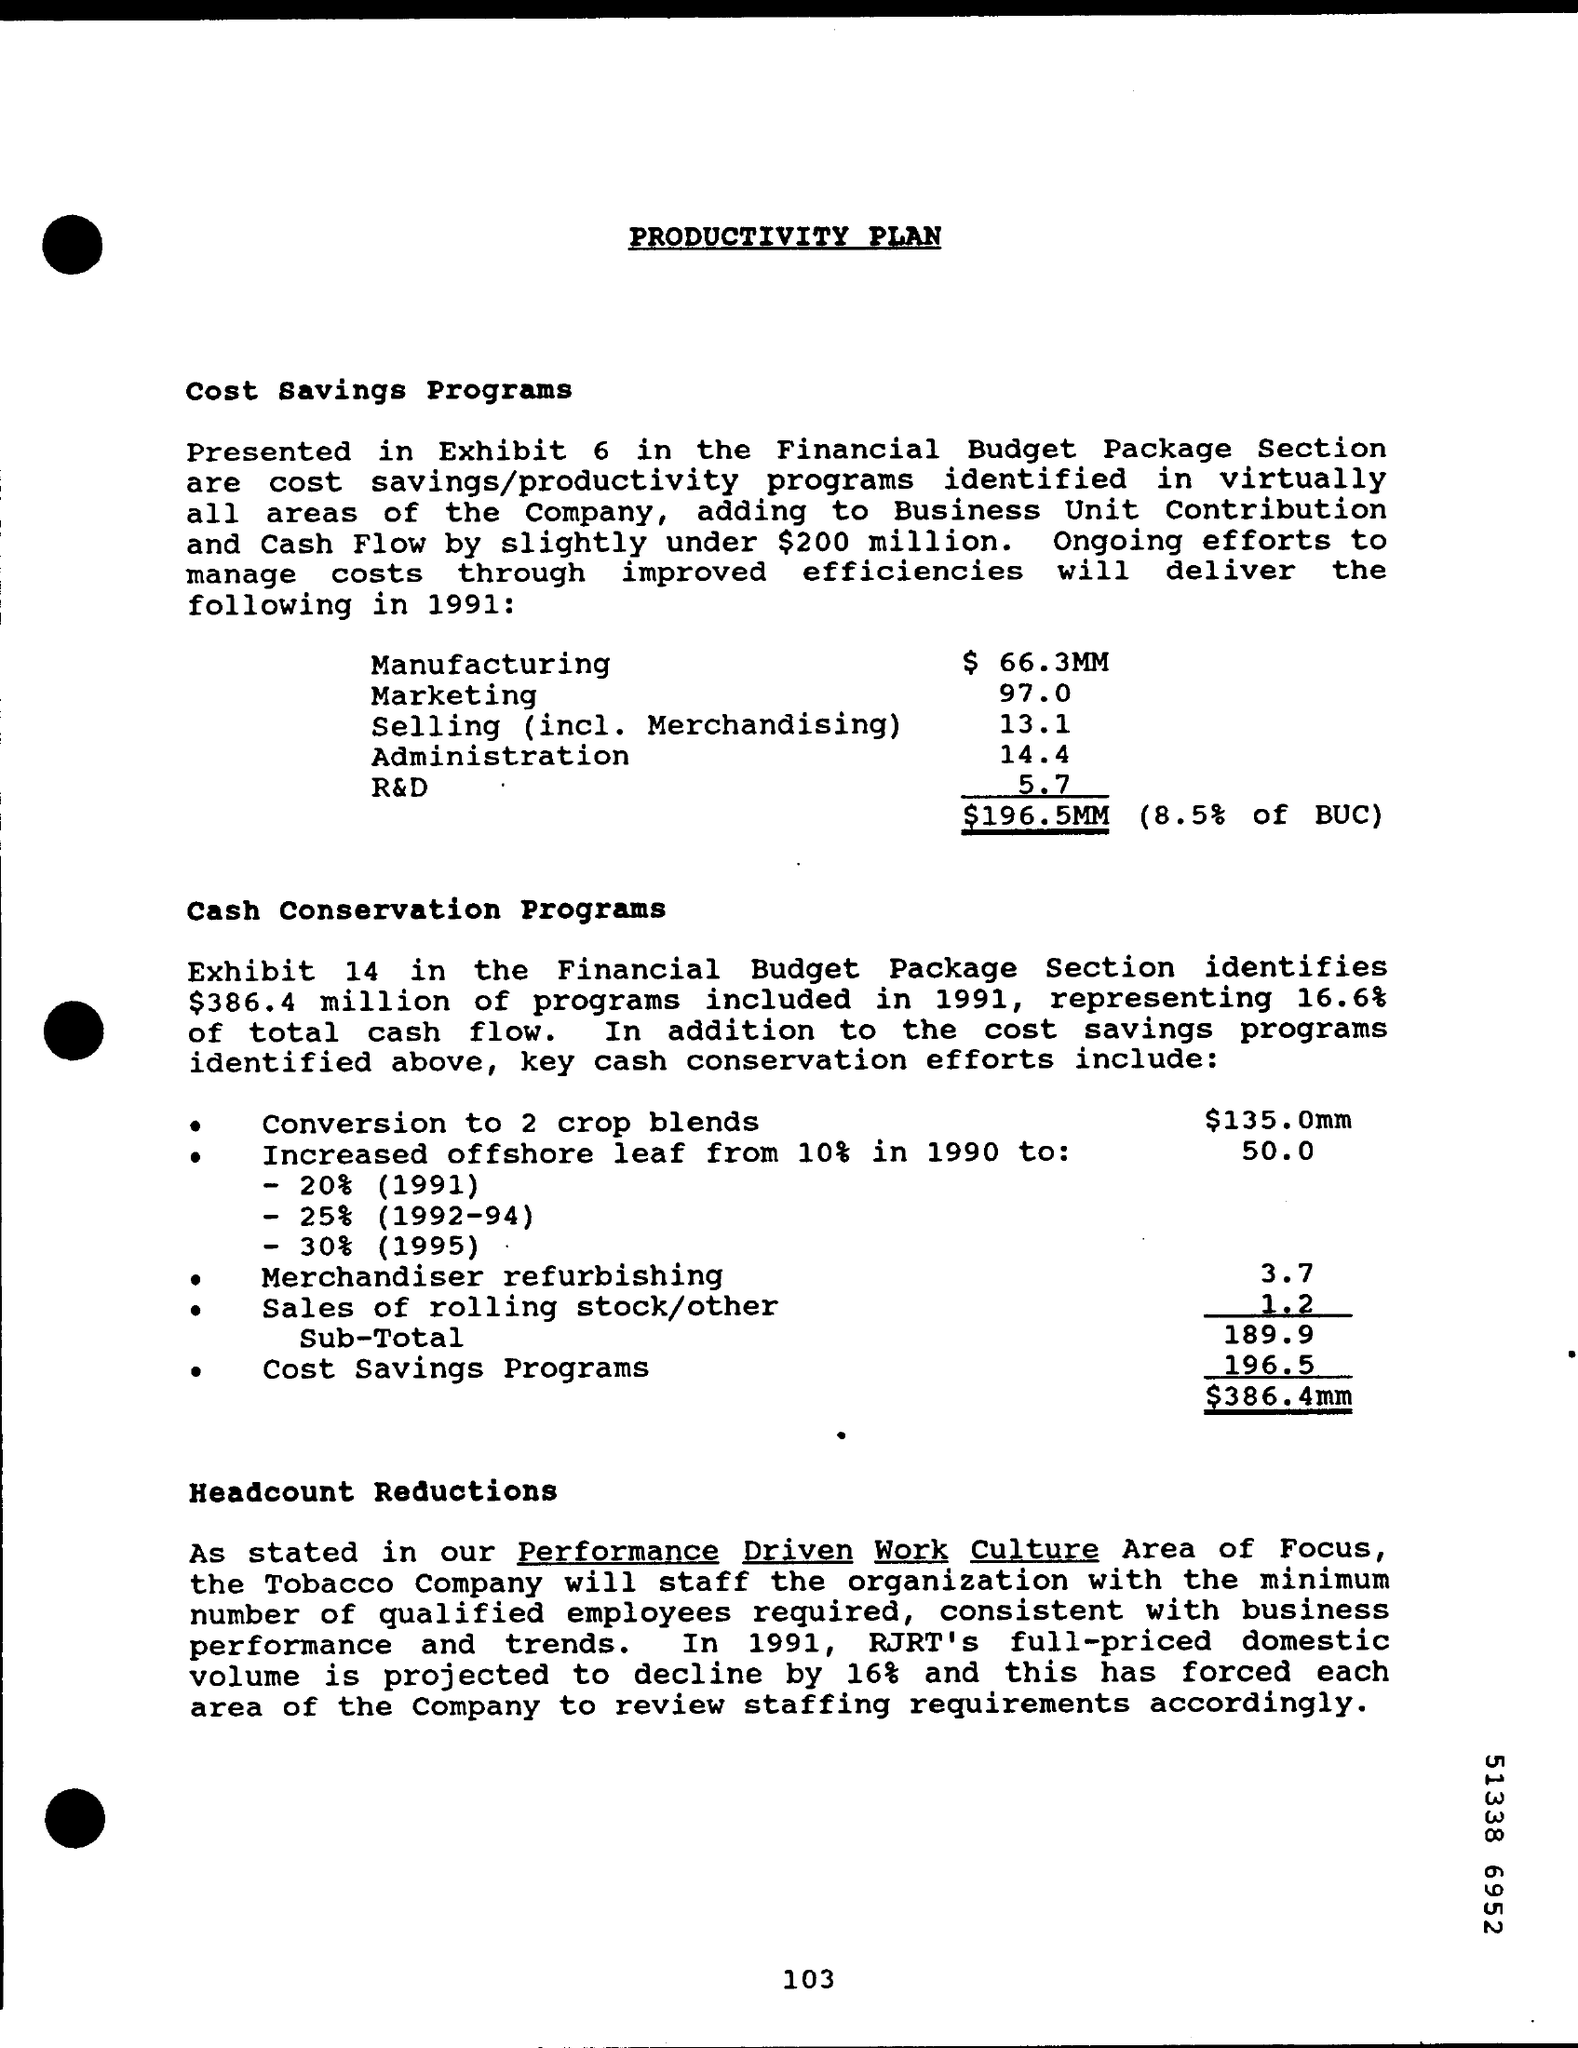How much is the total for the cost savings programs
Your answer should be very brief. $196.5MM. In 1991, RJRT's full priced domestic volume is projected to decline by how much %?
Make the answer very short. 16%. 